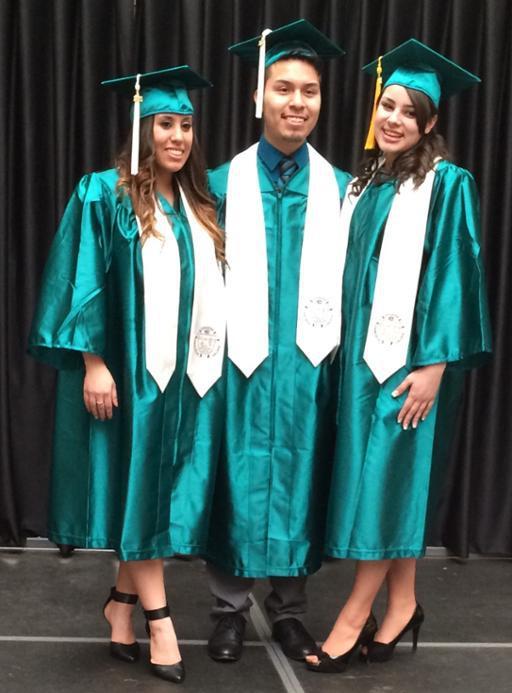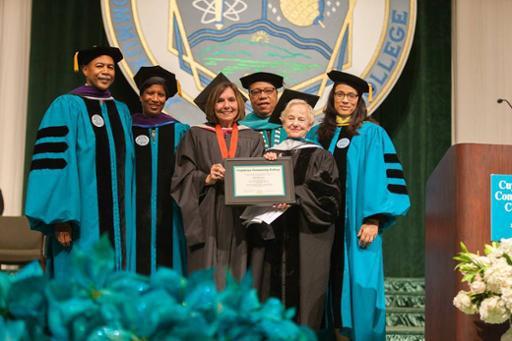The first image is the image on the left, the second image is the image on the right. Considering the images on both sides, is "Three people are posing together in graduation attire in one of the images." valid? Answer yes or no. Yes. The first image is the image on the left, the second image is the image on the right. Examine the images to the left and right. Is the description "One image shows a row of all front-facing graduates in black robes, and none wear colored sashes." accurate? Answer yes or no. No. 